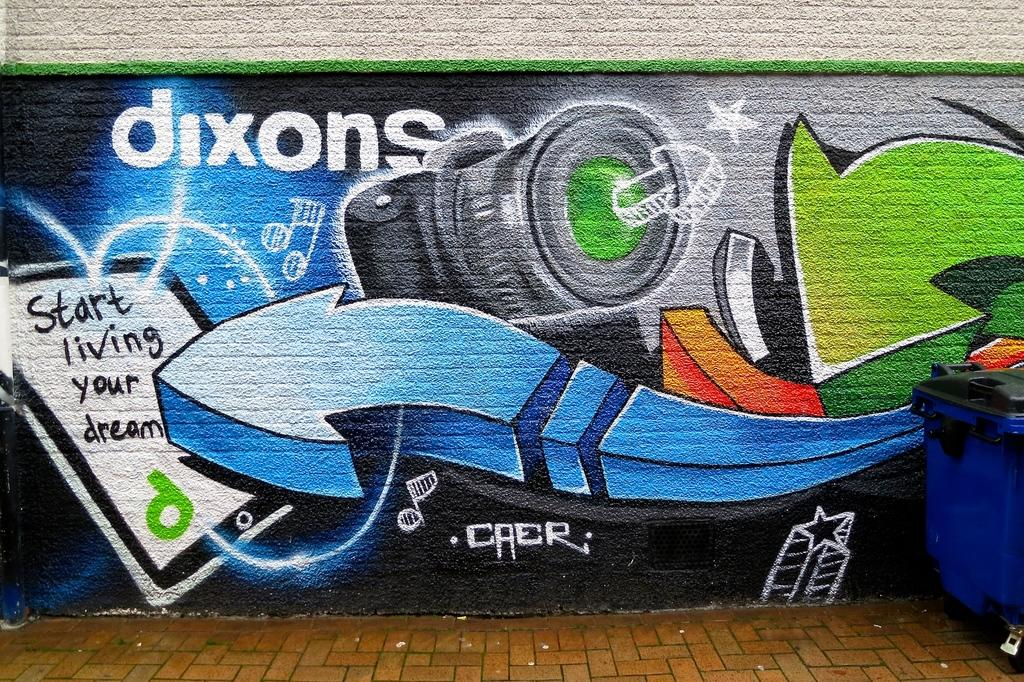<image>
Describe the image concisely. Art is displayed on the wall related to the Dixon camera and tablet. 